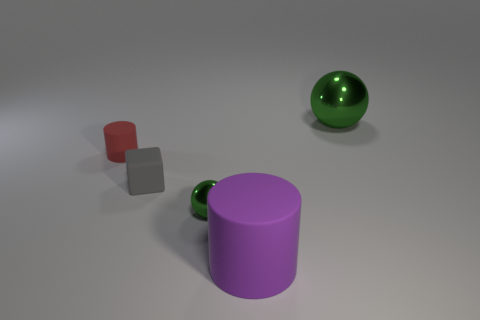Add 1 big things. How many objects exist? 6 Subtract all cubes. How many objects are left? 4 Add 1 small green metallic objects. How many small green metallic objects exist? 2 Subtract 0 purple balls. How many objects are left? 5 Subtract all purple cylinders. Subtract all small blocks. How many objects are left? 3 Add 2 small red cylinders. How many small red cylinders are left? 3 